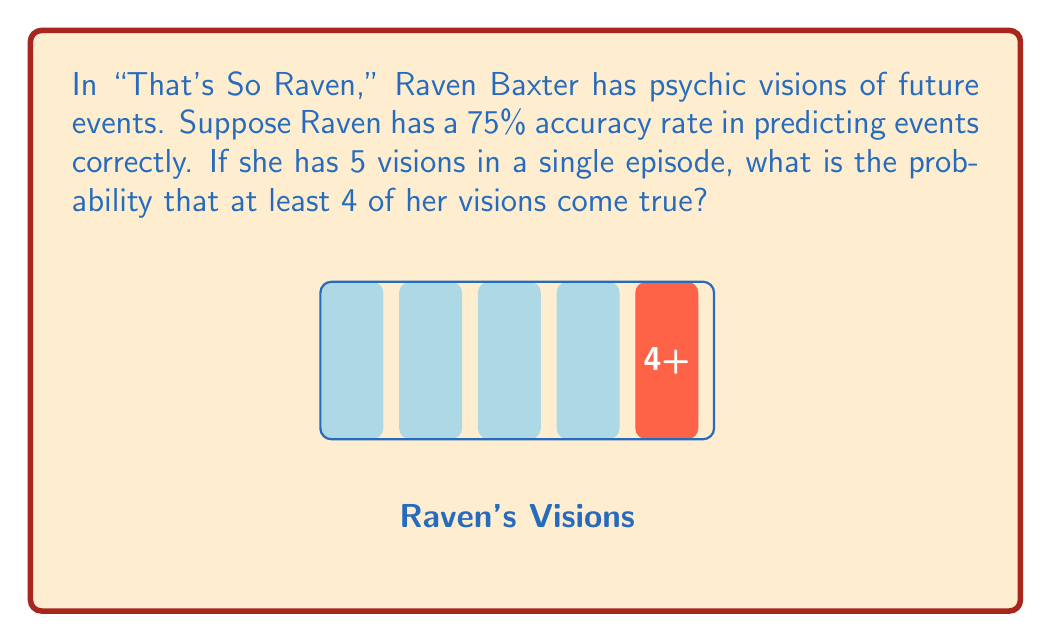Can you solve this math problem? Let's approach this step-by-step using the binomial probability formula:

1) We can model this scenario as a binomial distribution where:
   $n = 5$ (number of visions)
   $p = 0.75$ (probability of a correct vision)
   $X$ = number of correct visions

2) We want $P(X \geq 4)$, which is equal to $P(X = 4) + P(X = 5)$

3) The binomial probability formula is:

   $$P(X = k) = \binom{n}{k} p^k (1-p)^{n-k}$$

4) For $P(X = 4)$:
   $$P(X = 4) = \binom{5}{4} (0.75)^4 (0.25)^1 = 5 \cdot 0.75^4 \cdot 0.25 = 0.3955078125$$

5) For $P(X = 5)$:
   $$P(X = 5) = \binom{5}{5} (0.75)^5 (0.25)^0 = 1 \cdot 0.75^5 = 0.2373046875$$

6) Therefore, $P(X \geq 4) = P(X = 4) + P(X = 5) = 0.3955078125 + 0.2373046875 = 0.6328125$
Answer: $\frac{237}{375} \approx 0.6328$ 